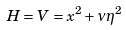Convert formula to latex. <formula><loc_0><loc_0><loc_500><loc_500>H = V = x ^ { 2 } + \nu \eta ^ { 2 }</formula> 